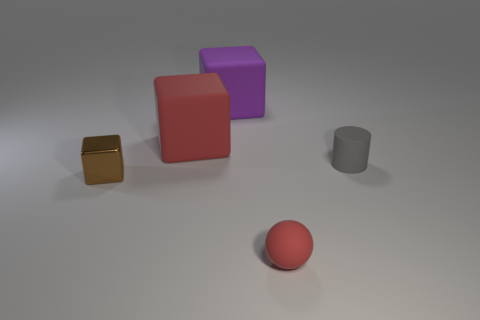Can you describe the lighting in the image? The lighting in the image appears soft and diffused, with gentle shadows behind the objects suggesting an overhead light source, contributing to the calm and balanced atmosphere of the scene. 